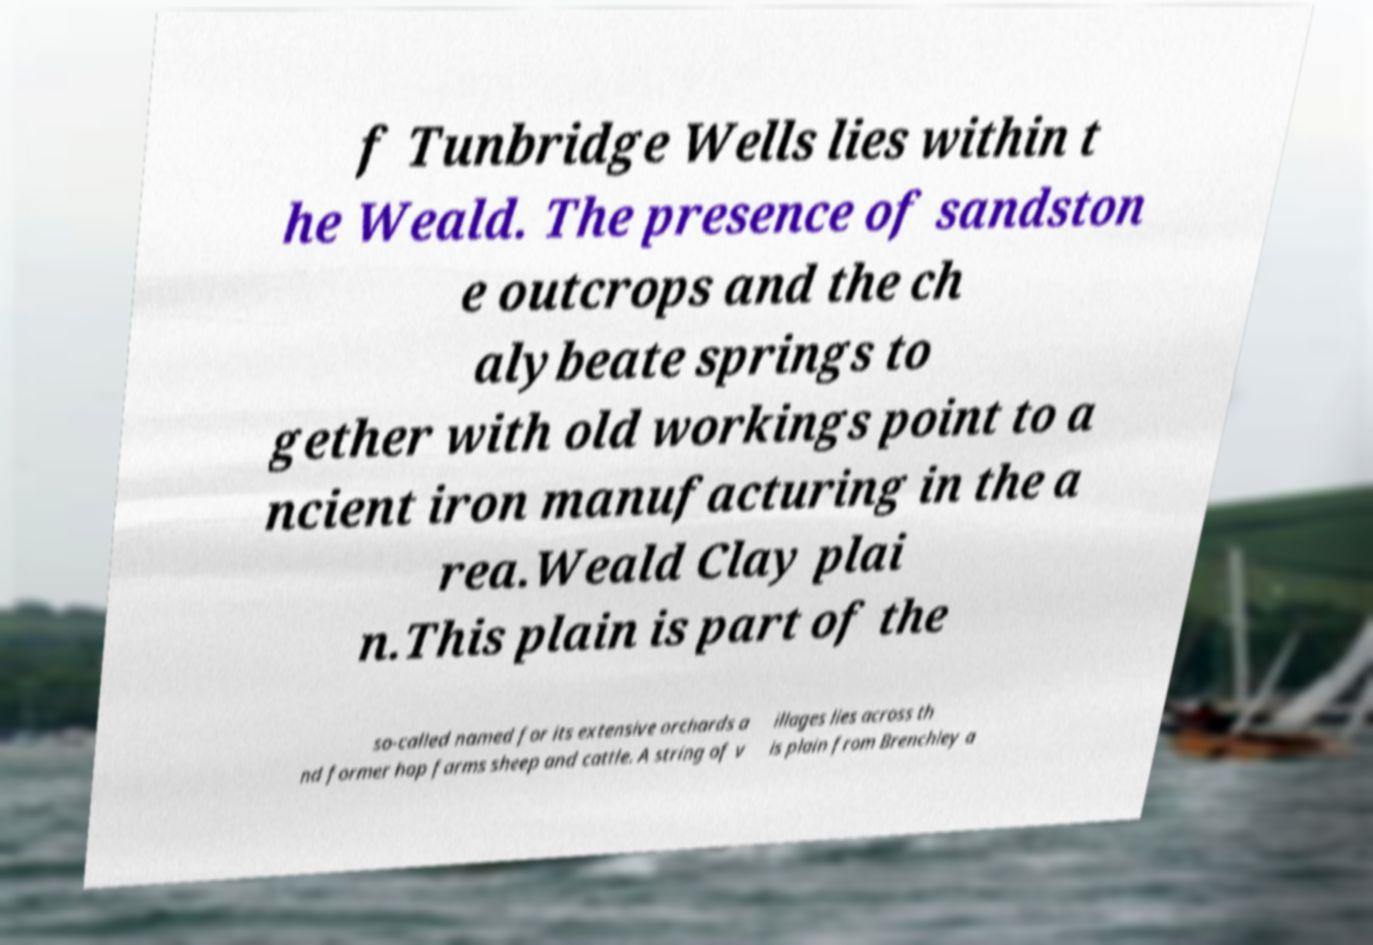Can you read and provide the text displayed in the image?This photo seems to have some interesting text. Can you extract and type it out for me? f Tunbridge Wells lies within t he Weald. The presence of sandston e outcrops and the ch alybeate springs to gether with old workings point to a ncient iron manufacturing in the a rea.Weald Clay plai n.This plain is part of the so-called named for its extensive orchards a nd former hop farms sheep and cattle. A string of v illages lies across th is plain from Brenchley a 